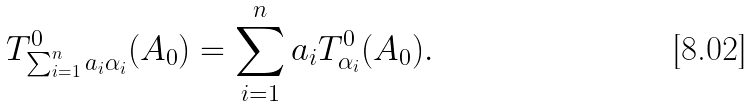<formula> <loc_0><loc_0><loc_500><loc_500>T ^ { 0 } _ { \sum _ { i = 1 } ^ { n } a _ { i } \alpha _ { i } } ( A _ { 0 } ) = \sum _ { i = 1 } ^ { n } a _ { i } T ^ { 0 } _ { \alpha _ { i } } ( A _ { 0 } ) .</formula> 